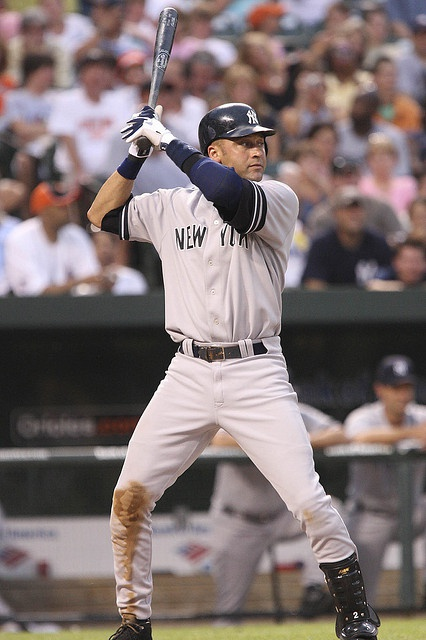Describe the objects in this image and their specific colors. I can see people in brown, lightgray, darkgray, and black tones, people in brown, gray, darkgray, and lavender tones, people in brown, gray, darkgray, and black tones, people in brown, gray, darkgray, and black tones, and people in brown, lavender, darkgray, and gray tones in this image. 